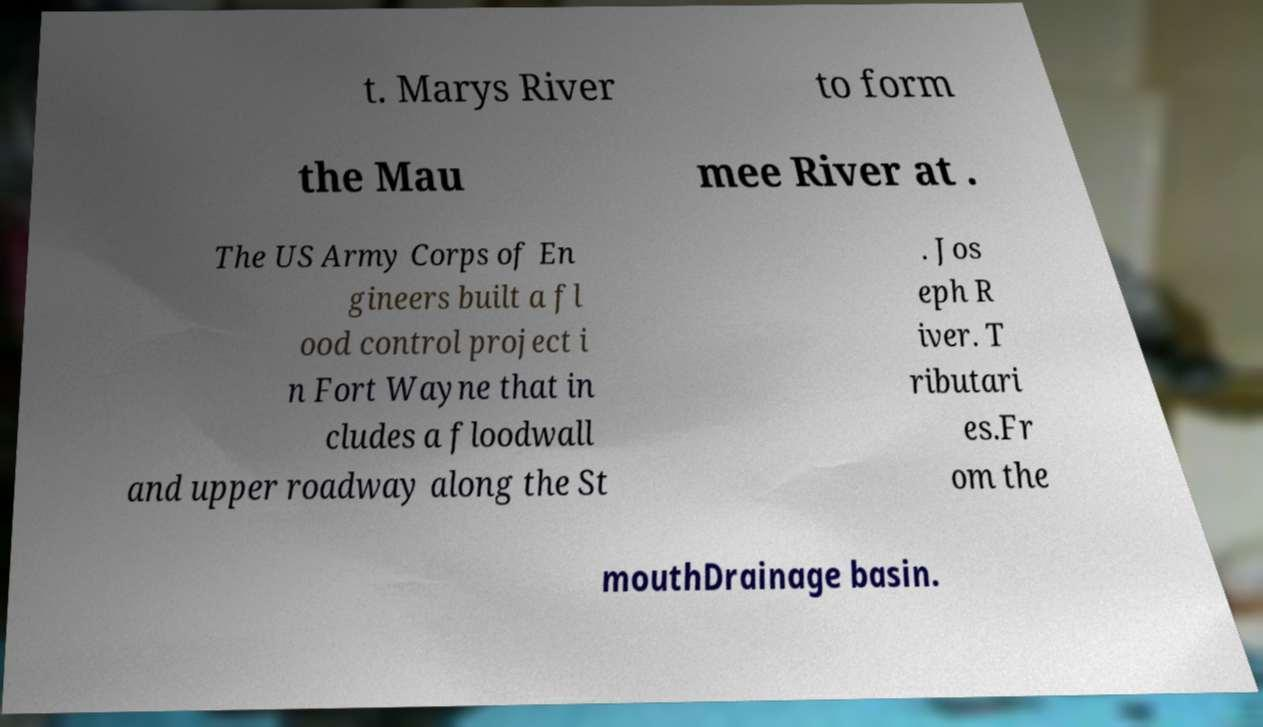Could you extract and type out the text from this image? t. Marys River to form the Mau mee River at . The US Army Corps of En gineers built a fl ood control project i n Fort Wayne that in cludes a floodwall and upper roadway along the St . Jos eph R iver. T ributari es.Fr om the mouthDrainage basin. 